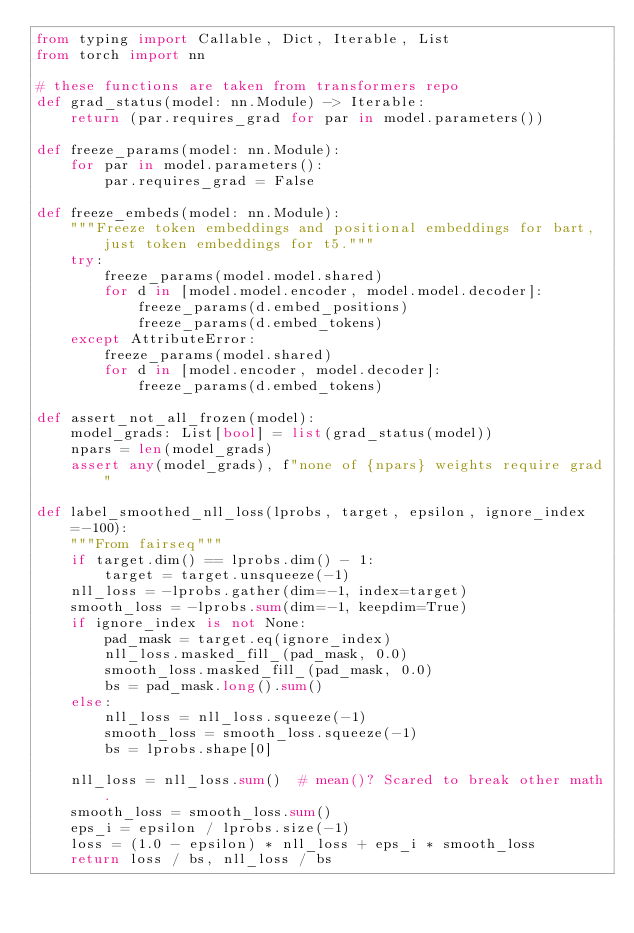Convert code to text. <code><loc_0><loc_0><loc_500><loc_500><_Python_>from typing import Callable, Dict, Iterable, List
from torch import nn

# these functions are taken from transformers repo
def grad_status(model: nn.Module) -> Iterable:
    return (par.requires_grad for par in model.parameters())

def freeze_params(model: nn.Module):
    for par in model.parameters():
        par.requires_grad = False

def freeze_embeds(model: nn.Module):
    """Freeze token embeddings and positional embeddings for bart, just token embeddings for t5."""
    try:
        freeze_params(model.model.shared)
        for d in [model.model.encoder, model.model.decoder]:
            freeze_params(d.embed_positions)
            freeze_params(d.embed_tokens)
    except AttributeError:
        freeze_params(model.shared)
        for d in [model.encoder, model.decoder]:
            freeze_params(d.embed_tokens)

def assert_not_all_frozen(model):
    model_grads: List[bool] = list(grad_status(model))
    npars = len(model_grads)
    assert any(model_grads), f"none of {npars} weights require grad"

def label_smoothed_nll_loss(lprobs, target, epsilon, ignore_index=-100):
    """From fairseq"""
    if target.dim() == lprobs.dim() - 1:
        target = target.unsqueeze(-1)
    nll_loss = -lprobs.gather(dim=-1, index=target)
    smooth_loss = -lprobs.sum(dim=-1, keepdim=True)
    if ignore_index is not None:
        pad_mask = target.eq(ignore_index)
        nll_loss.masked_fill_(pad_mask, 0.0)
        smooth_loss.masked_fill_(pad_mask, 0.0)
        bs = pad_mask.long().sum()
    else:
        nll_loss = nll_loss.squeeze(-1)
        smooth_loss = smooth_loss.squeeze(-1)
        bs = lprobs.shape[0]

    nll_loss = nll_loss.sum()  # mean()? Scared to break other math.
    smooth_loss = smooth_loss.sum()
    eps_i = epsilon / lprobs.size(-1)
    loss = (1.0 - epsilon) * nll_loss + eps_i * smooth_loss
    return loss / bs, nll_loss / bs</code> 